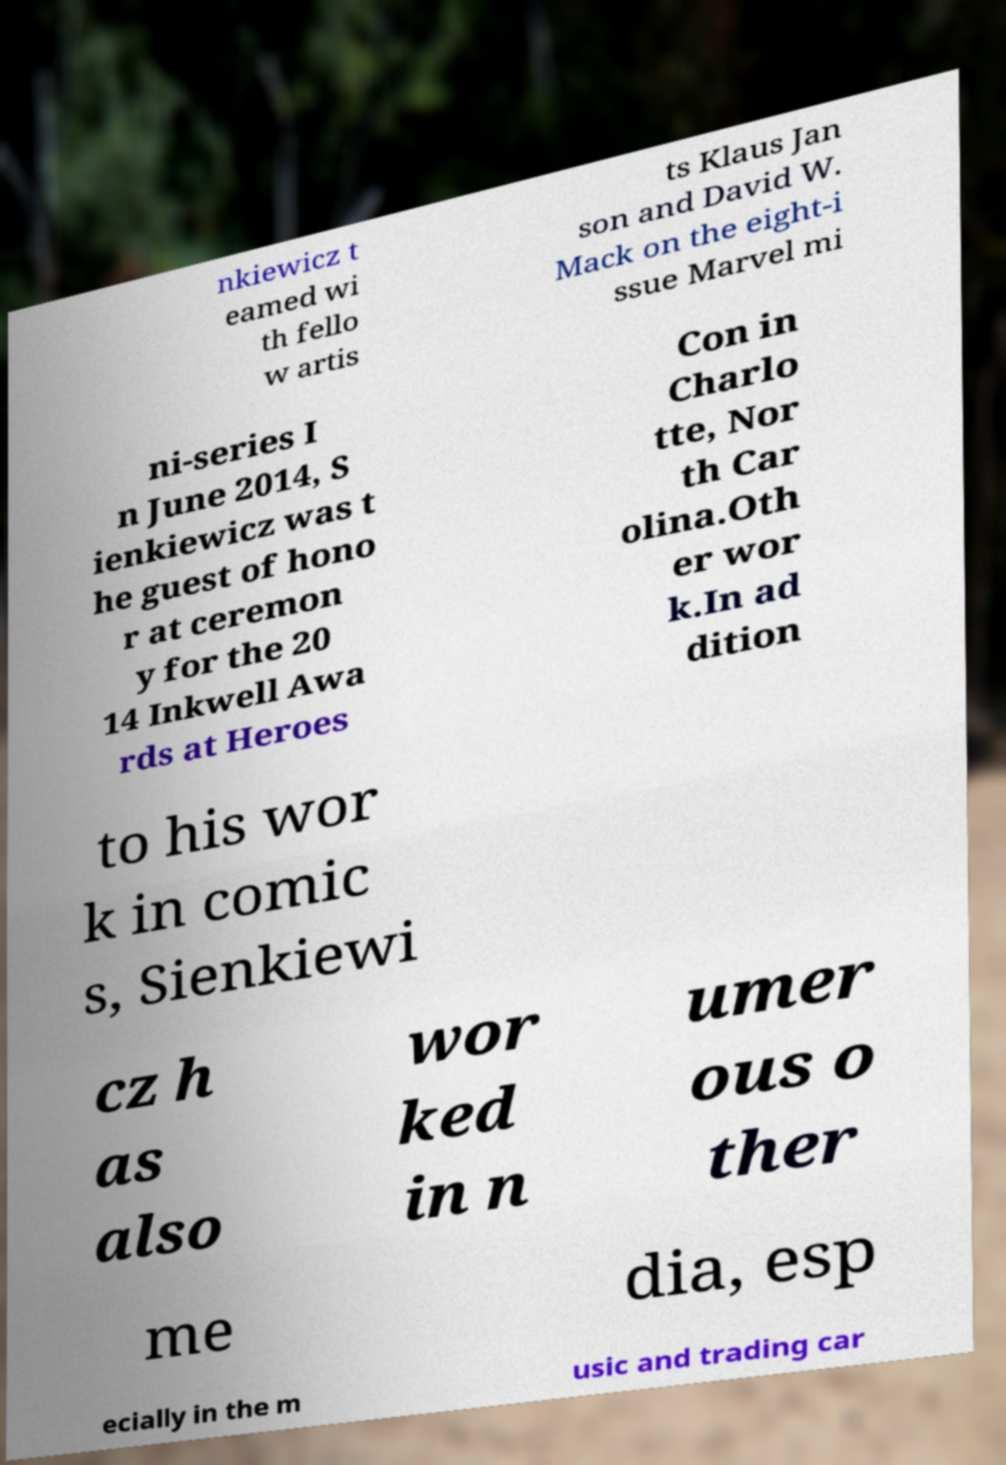There's text embedded in this image that I need extracted. Can you transcribe it verbatim? nkiewicz t eamed wi th fello w artis ts Klaus Jan son and David W. Mack on the eight-i ssue Marvel mi ni-series I n June 2014, S ienkiewicz was t he guest of hono r at ceremon y for the 20 14 Inkwell Awa rds at Heroes Con in Charlo tte, Nor th Car olina.Oth er wor k.In ad dition to his wor k in comic s, Sienkiewi cz h as also wor ked in n umer ous o ther me dia, esp ecially in the m usic and trading car 